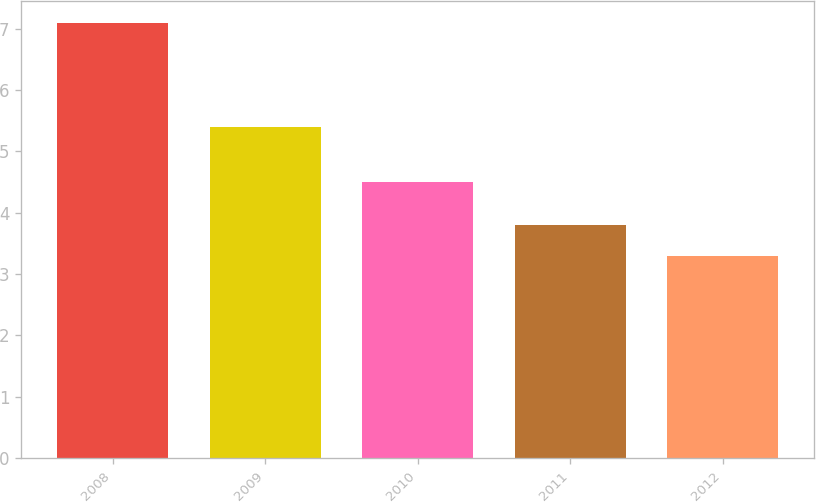Convert chart. <chart><loc_0><loc_0><loc_500><loc_500><bar_chart><fcel>2008<fcel>2009<fcel>2010<fcel>2011<fcel>2012<nl><fcel>7.1<fcel>5.4<fcel>4.5<fcel>3.8<fcel>3.3<nl></chart> 